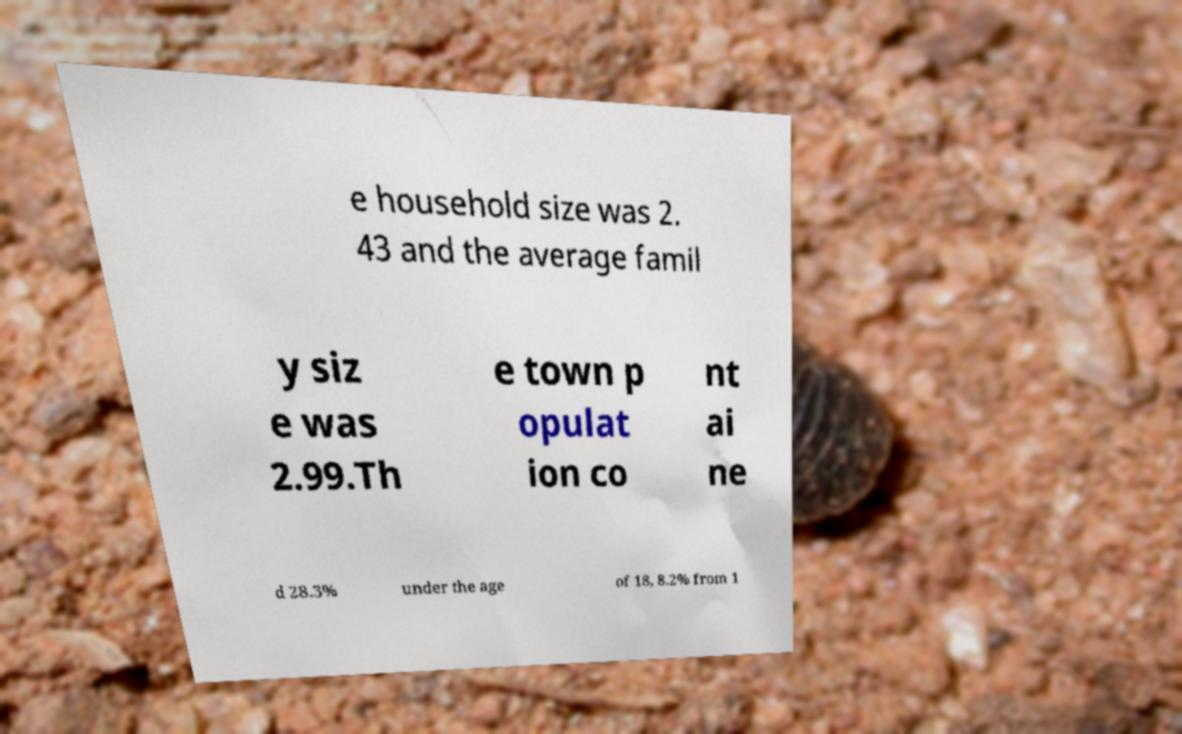For documentation purposes, I need the text within this image transcribed. Could you provide that? e household size was 2. 43 and the average famil y siz e was 2.99.Th e town p opulat ion co nt ai ne d 28.3% under the age of 18, 8.2% from 1 